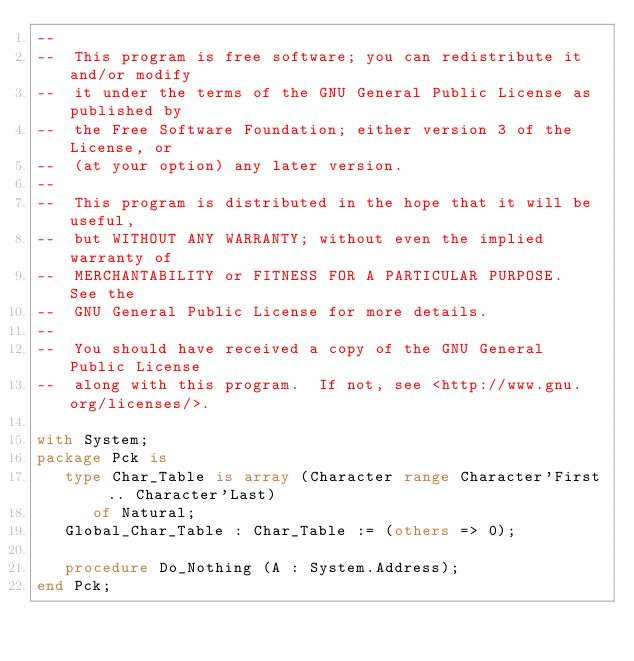Convert code to text. <code><loc_0><loc_0><loc_500><loc_500><_Ada_>--
--  This program is free software; you can redistribute it and/or modify
--  it under the terms of the GNU General Public License as published by
--  the Free Software Foundation; either version 3 of the License, or
--  (at your option) any later version.
--
--  This program is distributed in the hope that it will be useful,
--  but WITHOUT ANY WARRANTY; without even the implied warranty of
--  MERCHANTABILITY or FITNESS FOR A PARTICULAR PURPOSE.  See the
--  GNU General Public License for more details.
--
--  You should have received a copy of the GNU General Public License
--  along with this program.  If not, see <http://www.gnu.org/licenses/>.

with System;
package Pck is
   type Char_Table is array (Character range Character'First .. Character'Last)
      of Natural;
   Global_Char_Table : Char_Table := (others => 0);

   procedure Do_Nothing (A : System.Address);
end Pck;
</code> 